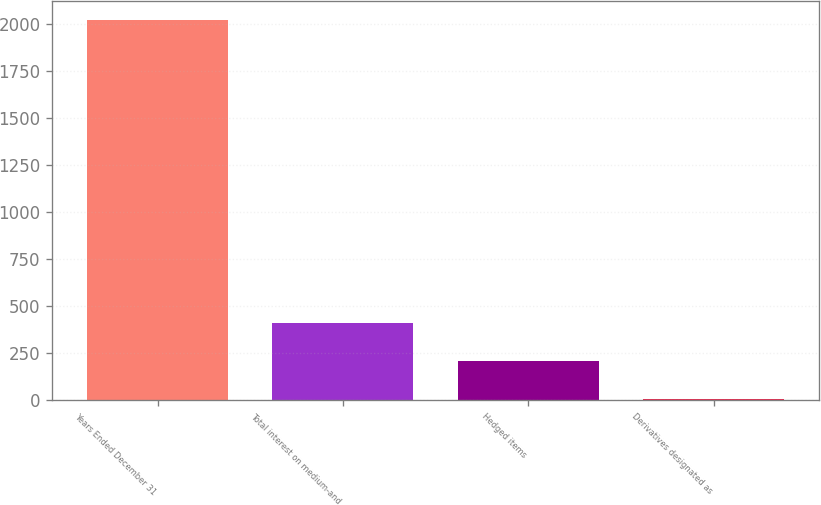Convert chart to OTSL. <chart><loc_0><loc_0><loc_500><loc_500><bar_chart><fcel>Years Ended December 31<fcel>Total interest on medium-and<fcel>Hedged items<fcel>Derivatives designated as<nl><fcel>2018<fcel>409.2<fcel>208.1<fcel>7<nl></chart> 